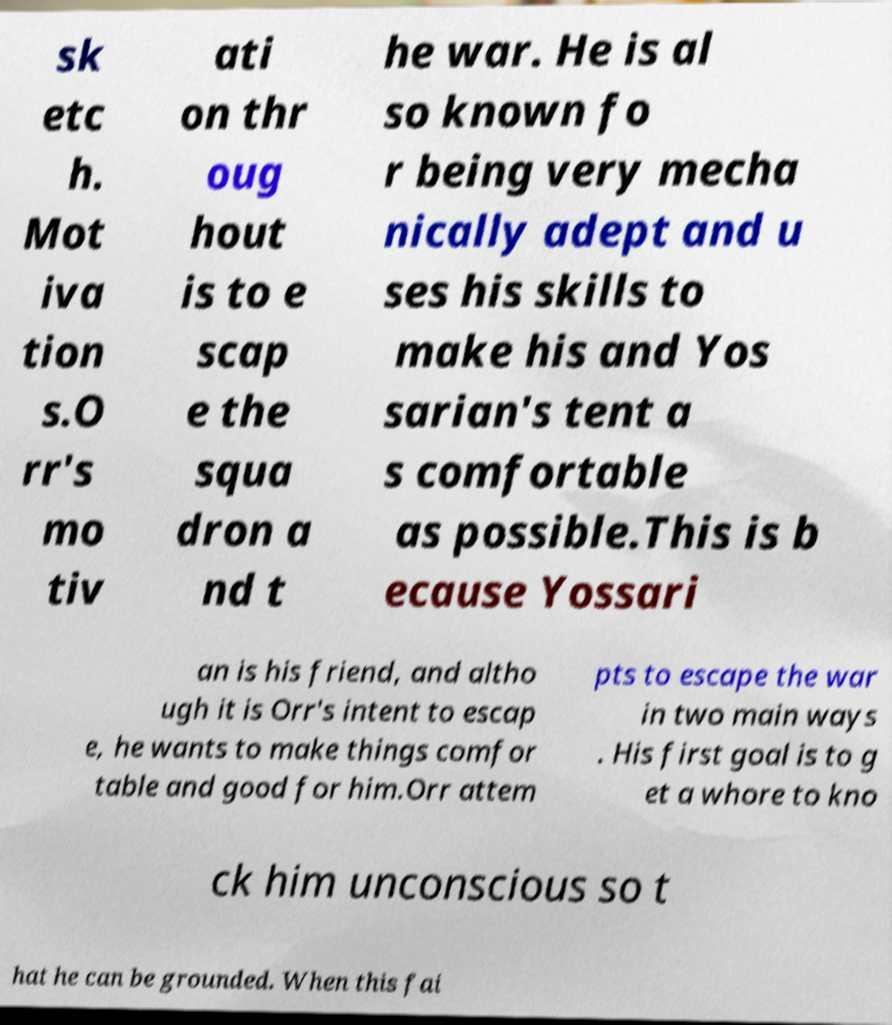Could you assist in decoding the text presented in this image and type it out clearly? sk etc h. Mot iva tion s.O rr's mo tiv ati on thr oug hout is to e scap e the squa dron a nd t he war. He is al so known fo r being very mecha nically adept and u ses his skills to make his and Yos sarian's tent a s comfortable as possible.This is b ecause Yossari an is his friend, and altho ugh it is Orr's intent to escap e, he wants to make things comfor table and good for him.Orr attem pts to escape the war in two main ways . His first goal is to g et a whore to kno ck him unconscious so t hat he can be grounded. When this fai 